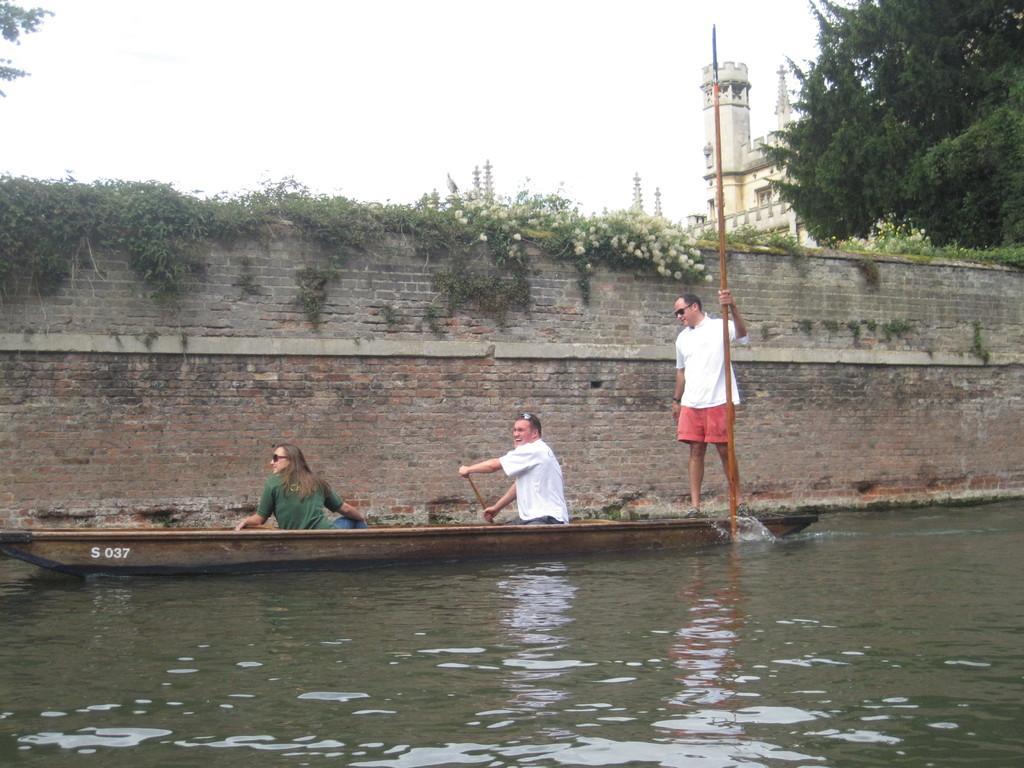In one or two sentences, can you explain what this image depicts? In the picture we can see a backwater with a boat with a man and woman sitting on it and one man is standing and holding a stick and beside the boat we can see a wall on top of the boat we can see some plants with flowers and beside it we can see a tree and building and in the background we can see a sky. 